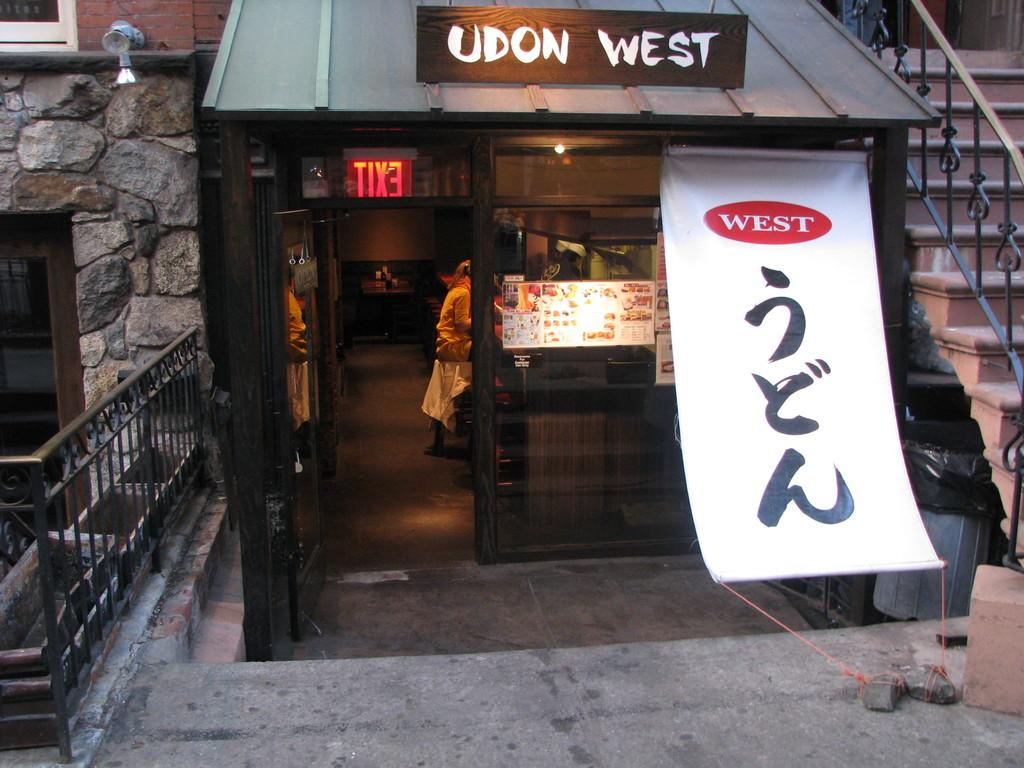<image>
Offer a succinct explanation of the picture presented. a banner in front of a store labelled west 